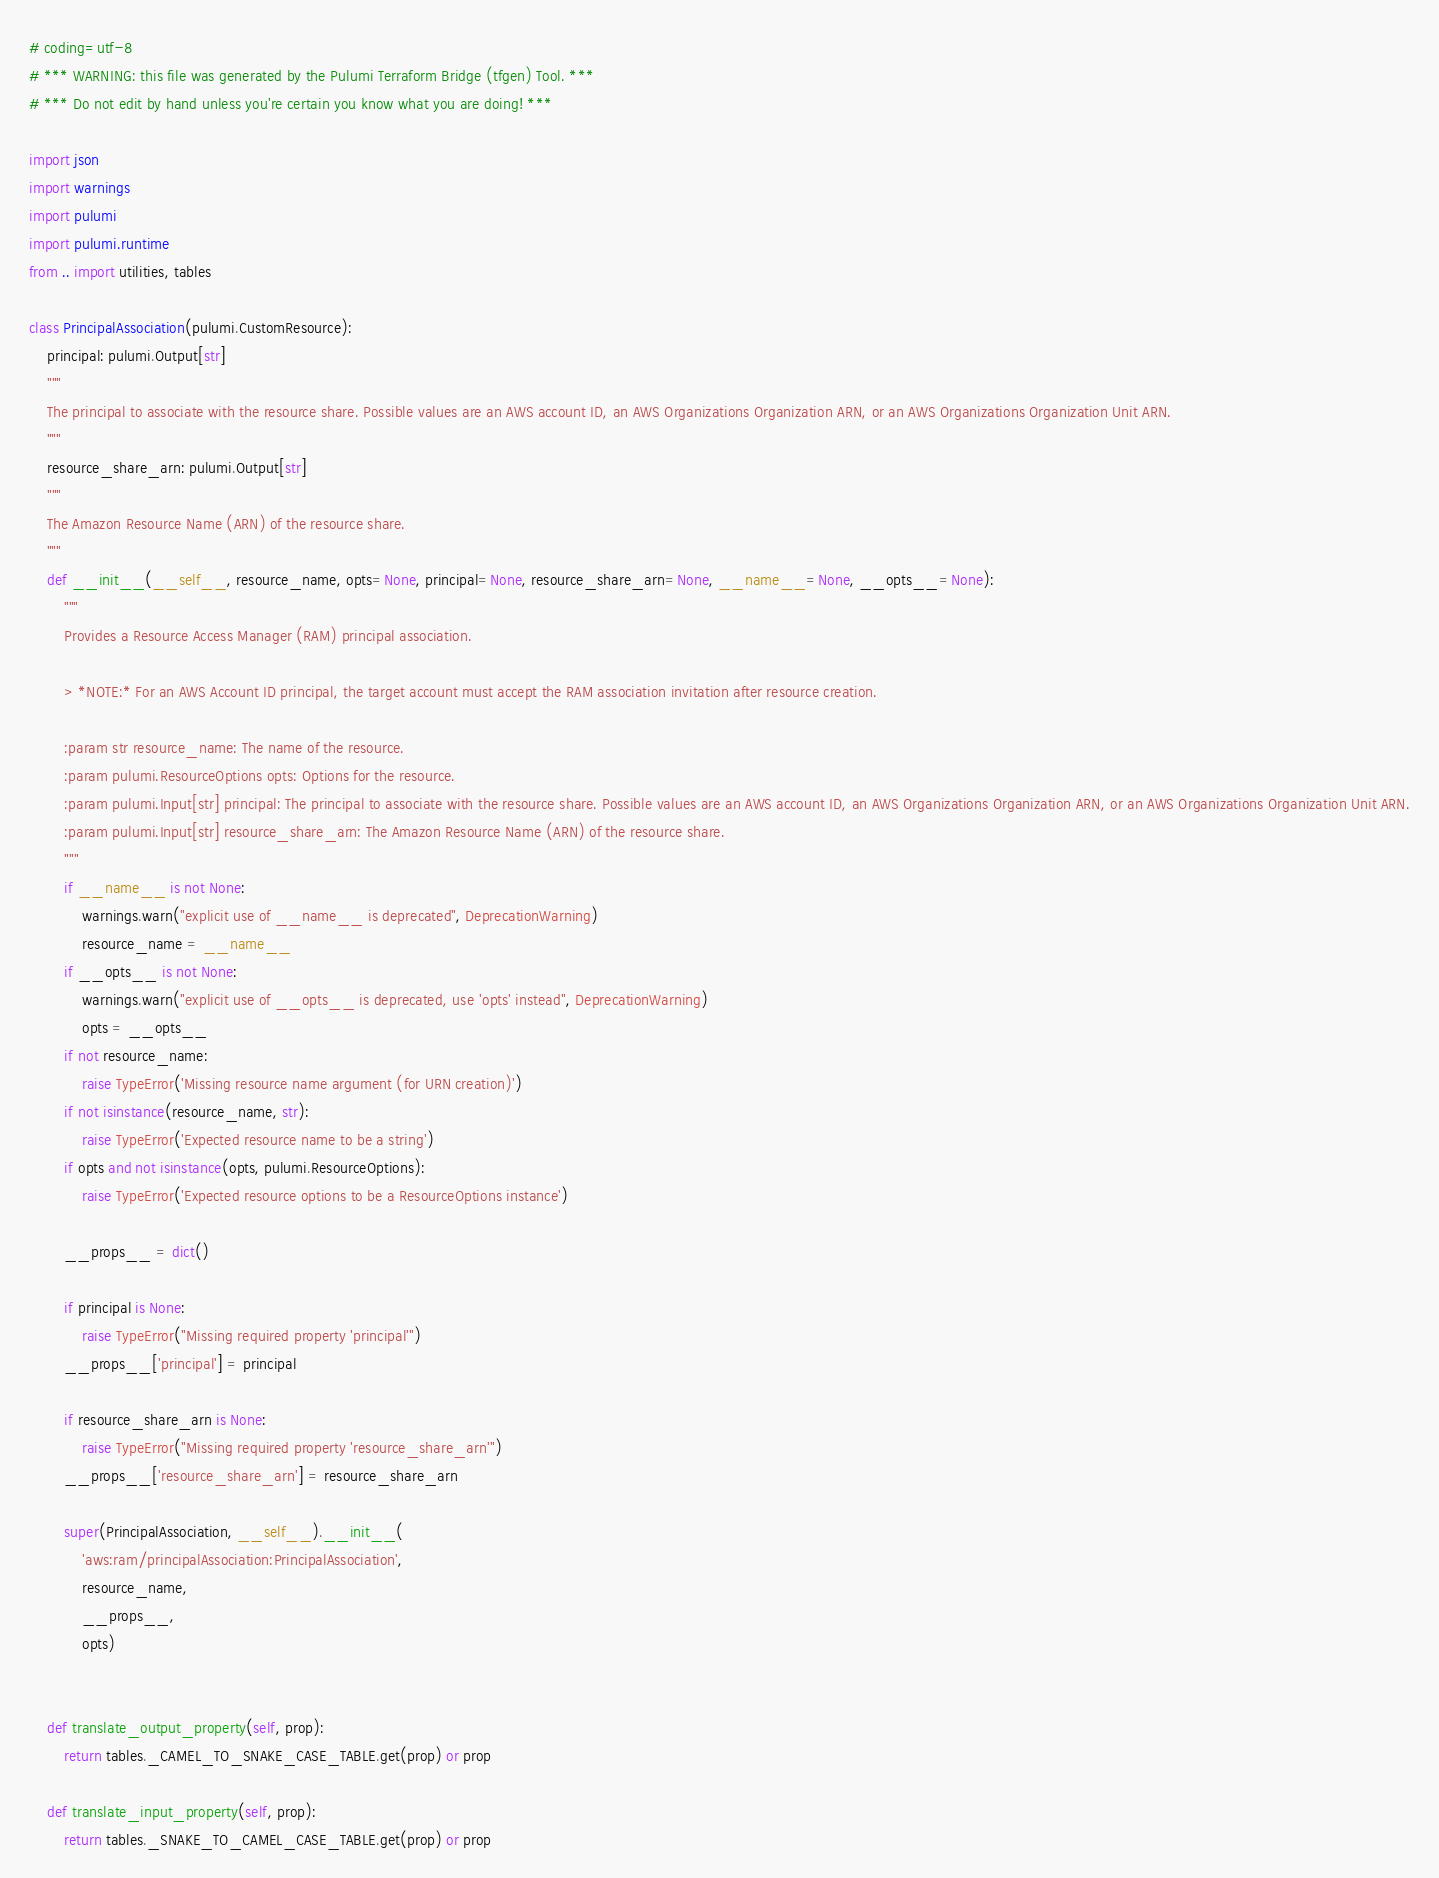Convert code to text. <code><loc_0><loc_0><loc_500><loc_500><_Python_># coding=utf-8
# *** WARNING: this file was generated by the Pulumi Terraform Bridge (tfgen) Tool. ***
# *** Do not edit by hand unless you're certain you know what you are doing! ***

import json
import warnings
import pulumi
import pulumi.runtime
from .. import utilities, tables

class PrincipalAssociation(pulumi.CustomResource):
    principal: pulumi.Output[str]
    """
    The principal to associate with the resource share. Possible values are an AWS account ID, an AWS Organizations Organization ARN, or an AWS Organizations Organization Unit ARN.
    """
    resource_share_arn: pulumi.Output[str]
    """
    The Amazon Resource Name (ARN) of the resource share.
    """
    def __init__(__self__, resource_name, opts=None, principal=None, resource_share_arn=None, __name__=None, __opts__=None):
        """
        Provides a Resource Access Manager (RAM) principal association.
        
        > *NOTE:* For an AWS Account ID principal, the target account must accept the RAM association invitation after resource creation.
        
        :param str resource_name: The name of the resource.
        :param pulumi.ResourceOptions opts: Options for the resource.
        :param pulumi.Input[str] principal: The principal to associate with the resource share. Possible values are an AWS account ID, an AWS Organizations Organization ARN, or an AWS Organizations Organization Unit ARN.
        :param pulumi.Input[str] resource_share_arn: The Amazon Resource Name (ARN) of the resource share.
        """
        if __name__ is not None:
            warnings.warn("explicit use of __name__ is deprecated", DeprecationWarning)
            resource_name = __name__
        if __opts__ is not None:
            warnings.warn("explicit use of __opts__ is deprecated, use 'opts' instead", DeprecationWarning)
            opts = __opts__
        if not resource_name:
            raise TypeError('Missing resource name argument (for URN creation)')
        if not isinstance(resource_name, str):
            raise TypeError('Expected resource name to be a string')
        if opts and not isinstance(opts, pulumi.ResourceOptions):
            raise TypeError('Expected resource options to be a ResourceOptions instance')

        __props__ = dict()

        if principal is None:
            raise TypeError("Missing required property 'principal'")
        __props__['principal'] = principal

        if resource_share_arn is None:
            raise TypeError("Missing required property 'resource_share_arn'")
        __props__['resource_share_arn'] = resource_share_arn

        super(PrincipalAssociation, __self__).__init__(
            'aws:ram/principalAssociation:PrincipalAssociation',
            resource_name,
            __props__,
            opts)


    def translate_output_property(self, prop):
        return tables._CAMEL_TO_SNAKE_CASE_TABLE.get(prop) or prop

    def translate_input_property(self, prop):
        return tables._SNAKE_TO_CAMEL_CASE_TABLE.get(prop) or prop

</code> 